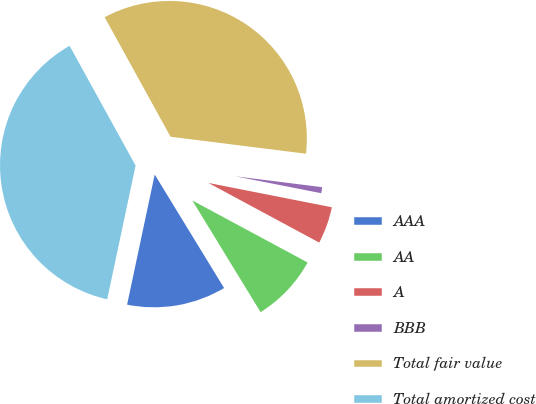Convert chart to OTSL. <chart><loc_0><loc_0><loc_500><loc_500><pie_chart><fcel>AAA<fcel>AA<fcel>A<fcel>BBB<fcel>Total fair value<fcel>Total amortized cost<nl><fcel>12.06%<fcel>8.41%<fcel>4.76%<fcel>1.11%<fcel>35.0%<fcel>38.65%<nl></chart> 